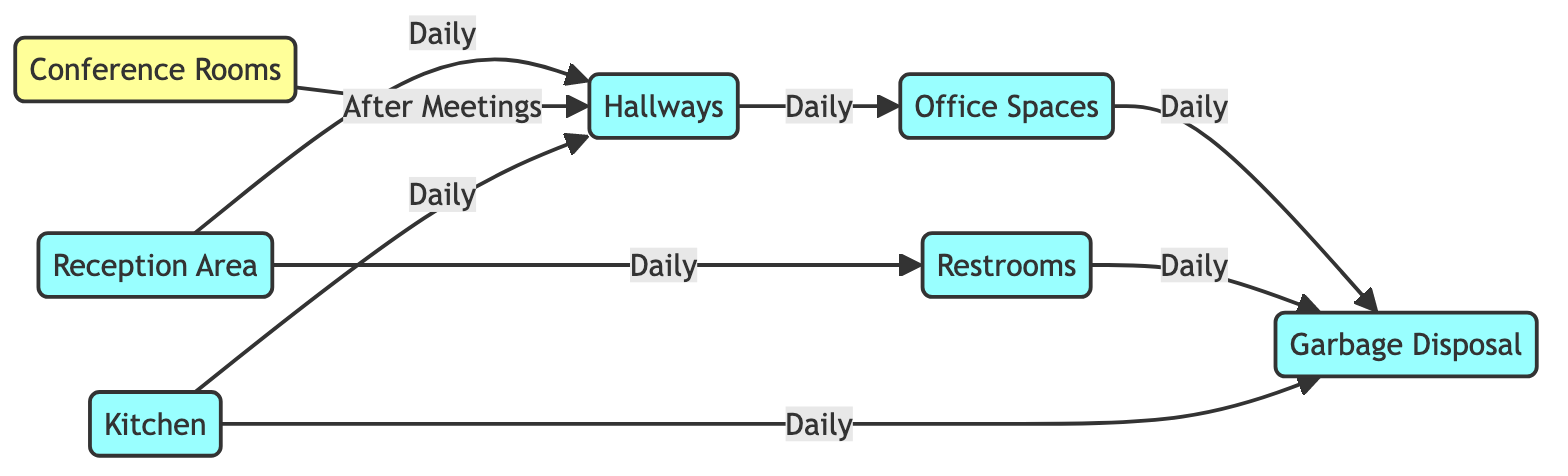What's the total number of cleaning zones in the diagram? The diagram includes seven nodes representing different cleaning zones: Reception Area, Hallways, Conference Rooms, Restrooms, Office Spaces, Kitchen, and Garbage Disposal. Counting these nodes gives a total of seven cleaning zones.
Answer: seven How many edges are there in total? The diagram has eight edges representing the connections between different cleaning zones. These edges indicate the cleaning schedule and relationships between the nodes. So counting them results in a total of eight edges.
Answer: eight Which areas require daily cleaning? From the diagram, the areas that require daily cleaning are the Reception Area, Hallways, Office Spaces, Restrooms, Kitchen, and Garbage Disposal. Each of these zones has a connection labeled "Daily," which shows their cleaning frequency.
Answer: Reception Area, Hallways, Office Spaces, Restrooms, Kitchen, Garbage Disposal What is the cleaning schedule for the Conference Rooms? The Conference Rooms have a cleaning schedule labeled "After Meetings," indicating that the cleaning occurs only after meetings are held, rather than on a daily basis.
Answer: After Meetings Which area is directly connected to the Garbage Disposal? The Garbage Disposal is directly connected to the Office Spaces, Restrooms, and Kitchen. Each of these areas has an edge leading to the Garbage Disposal, indicating their relationships in the cleaning process.
Answer: Office Spaces, Restrooms, Kitchen How does the cleaning of Hallways relate to Conference Rooms? The Hallways are connected to the Conference Rooms by an edge labeled "After Meetings." This indicates that the cleaning of Hallways is required after the Conference Rooms have been used. Hence, the Hallways serve as a transition between Conference Rooms and other areas.
Answer: After Meetings Which zones connect to the Hallways for daily cleaning? The zones connecting to Hallways for daily cleaning are Reception Area, Office Spaces, and Kitchen. Each of these areas has a direct edge leading to Hallways marked "Daily," thus reflecting their routine cleaning connection.
Answer: Reception Area, Office Spaces, Kitchen What implies the edge labeled "Daily" between the Restrooms and Garbage Disposal? The edge labeled "Daily" between the Restrooms and Garbage Disposal indicates that the cleaning of the Restrooms occurs every day, and its waste is promptly disposed of in the Garbage Disposal. This highlights the importance of keeping restrooms maintained regularly.
Answer: Daily 